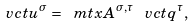<formula> <loc_0><loc_0><loc_500><loc_500>\ v c t { u } ^ { \sigma } = \ m t x { A } ^ { \sigma , \tau } \, \ v c t { q } ^ { \tau } ,</formula> 